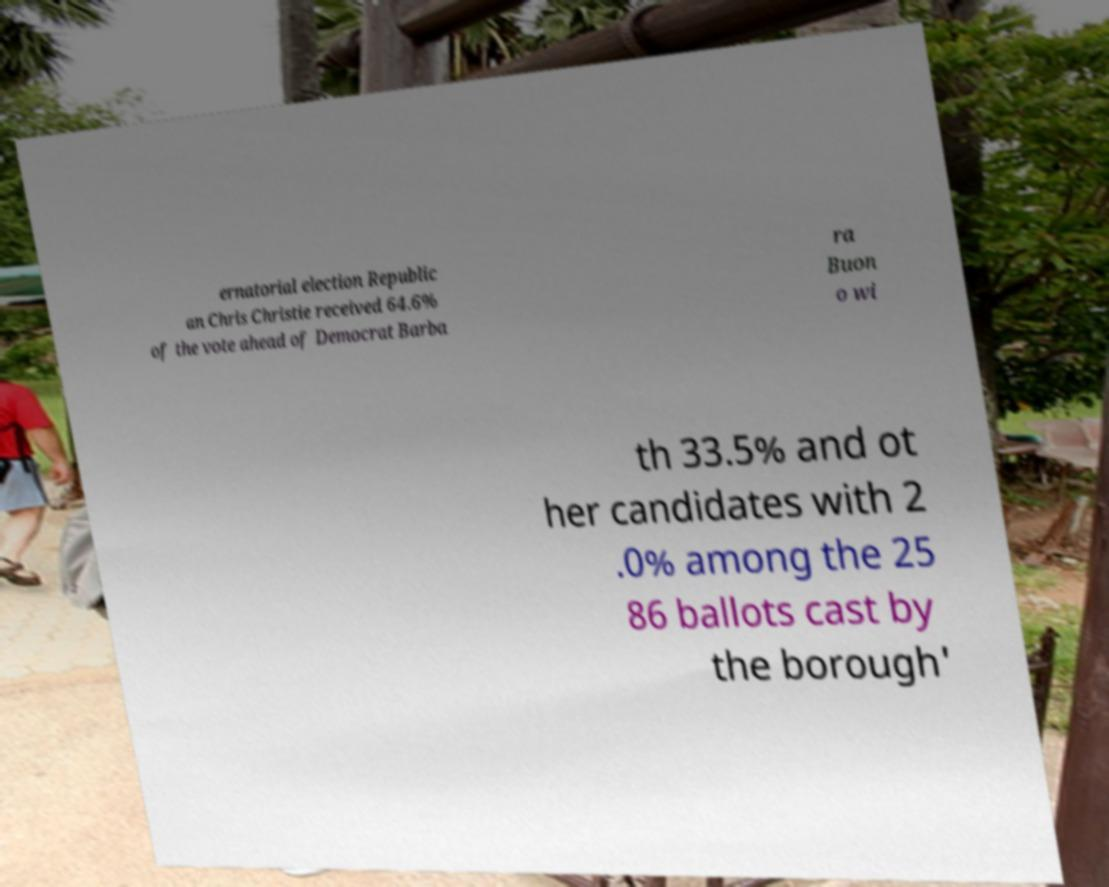What messages or text are displayed in this image? I need them in a readable, typed format. ernatorial election Republic an Chris Christie received 64.6% of the vote ahead of Democrat Barba ra Buon o wi th 33.5% and ot her candidates with 2 .0% among the 25 86 ballots cast by the borough' 